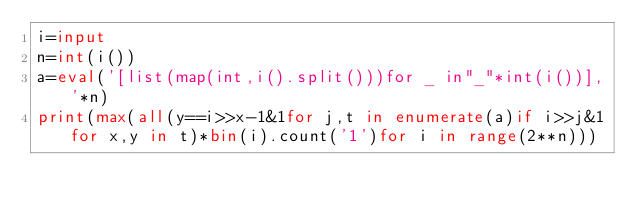<code> <loc_0><loc_0><loc_500><loc_500><_Python_>i=input
n=int(i())
a=eval('[list(map(int,i().split()))for _ in"_"*int(i())],'*n)
print(max(all(y==i>>x-1&1for j,t in enumerate(a)if i>>j&1for x,y in t)*bin(i).count('1')for i in range(2**n)))</code> 